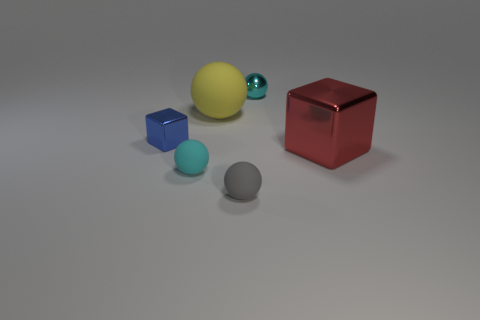There is a tiny metallic object to the left of the tiny metal sphere; how many small cyan balls are behind it?
Give a very brief answer. 1. Do the rubber thing behind the red metal thing and the tiny shiny thing left of the yellow thing have the same shape?
Keep it short and to the point. No. There is a metal thing that is both to the right of the yellow thing and to the left of the big shiny block; what size is it?
Your response must be concise. Small. What color is the other big metal thing that is the same shape as the blue metal object?
Offer a terse response. Red. There is a metallic block left of the cyan object that is behind the cyan rubber thing; what color is it?
Ensure brevity in your answer.  Blue. The tiny blue metallic thing is what shape?
Provide a succinct answer. Cube. What shape is the tiny object that is both behind the large metal object and on the left side of the yellow ball?
Give a very brief answer. Cube. There is a tiny cube that is made of the same material as the big red object; what color is it?
Give a very brief answer. Blue. What is the shape of the metallic thing that is behind the block on the left side of the cube to the right of the tiny blue object?
Offer a terse response. Sphere. The red block has what size?
Provide a short and direct response. Large. 